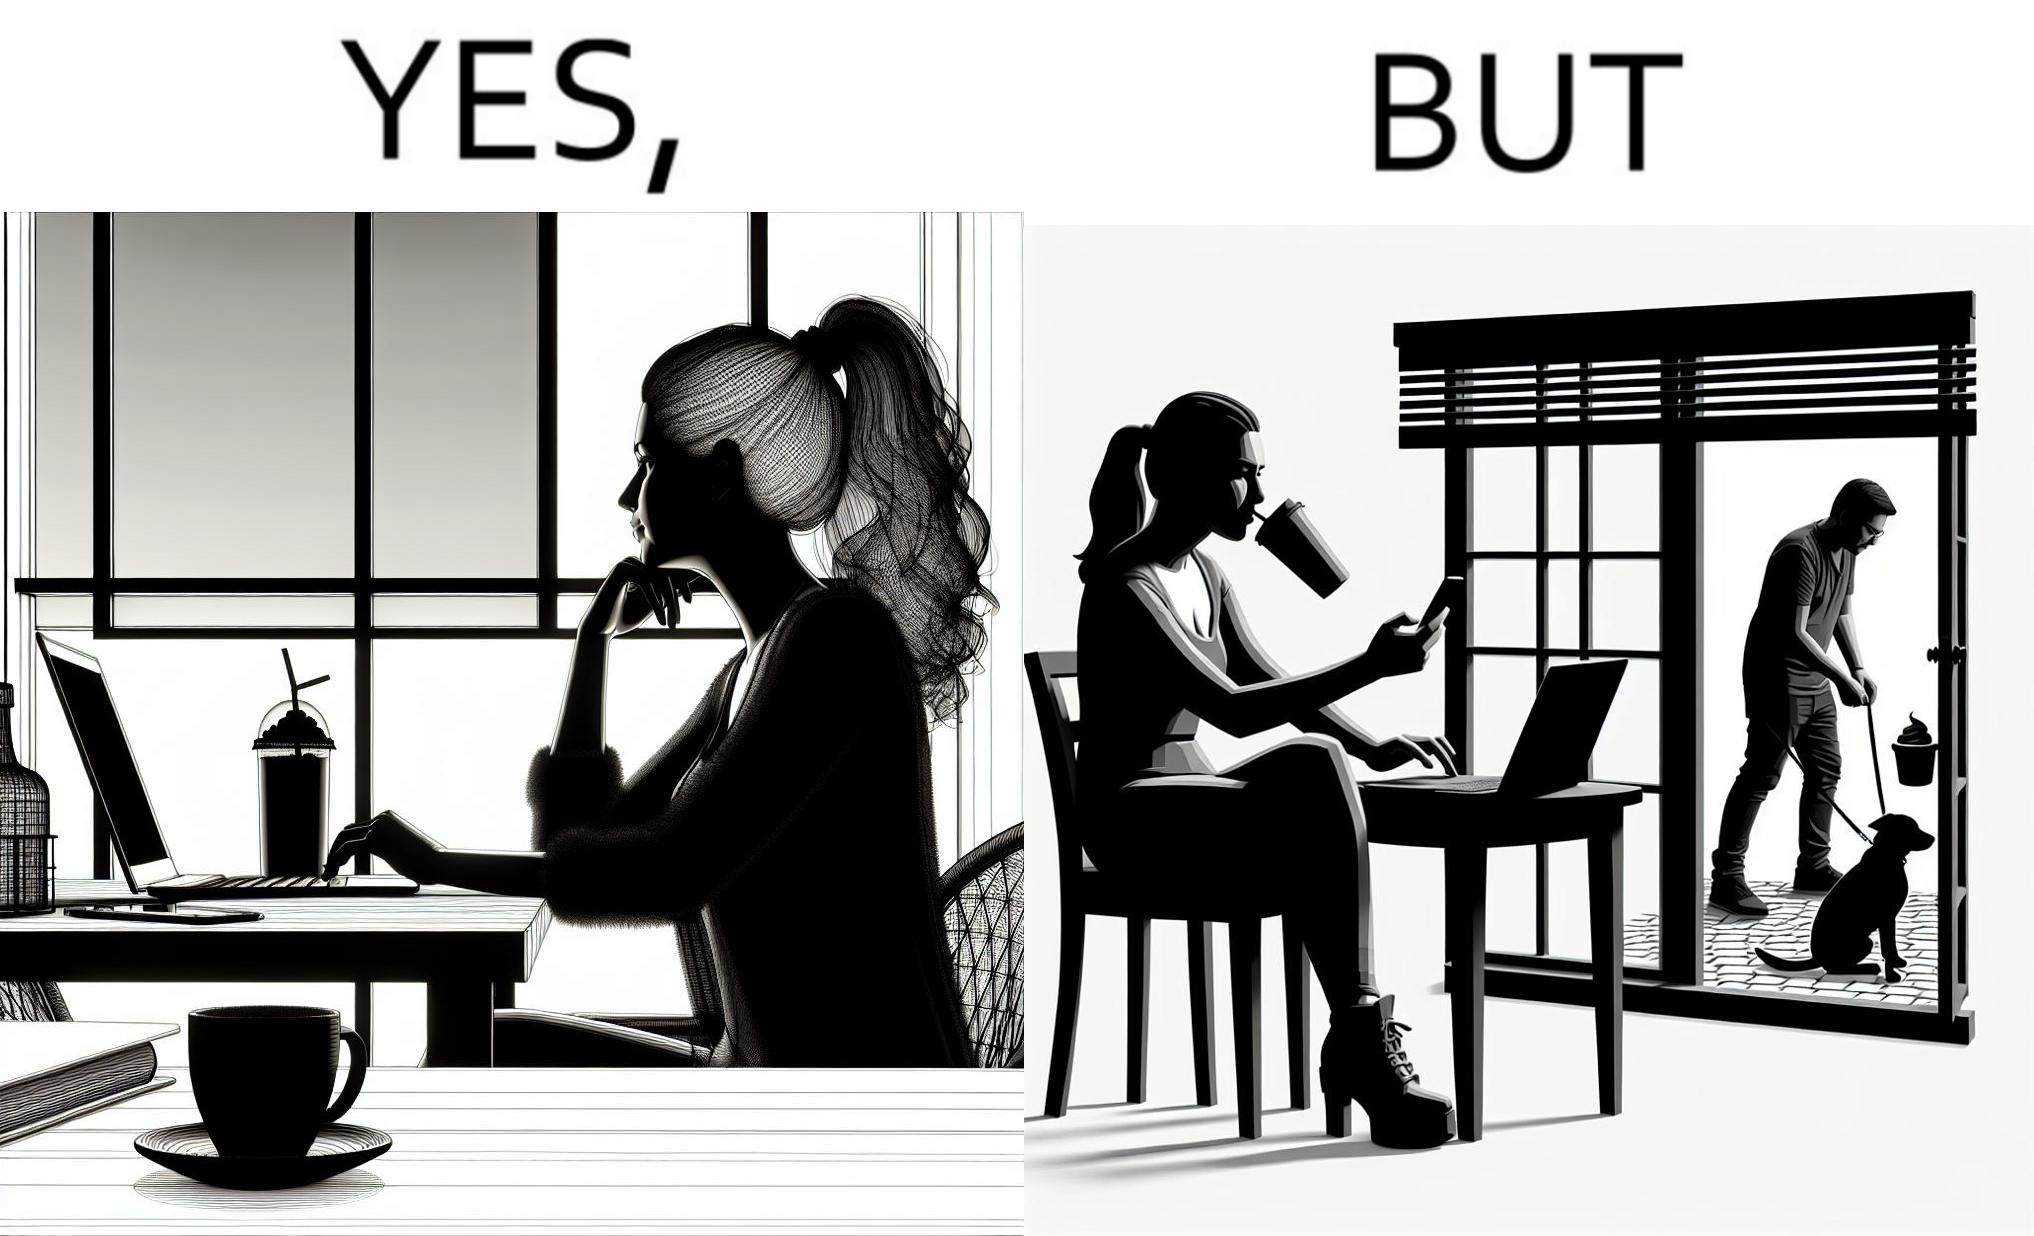Explain the humor or irony in this image. The image is ironic, because in the first image the woman is seen as enjoying the view but in the second image the same woman is seen as looking at a pooping dog 